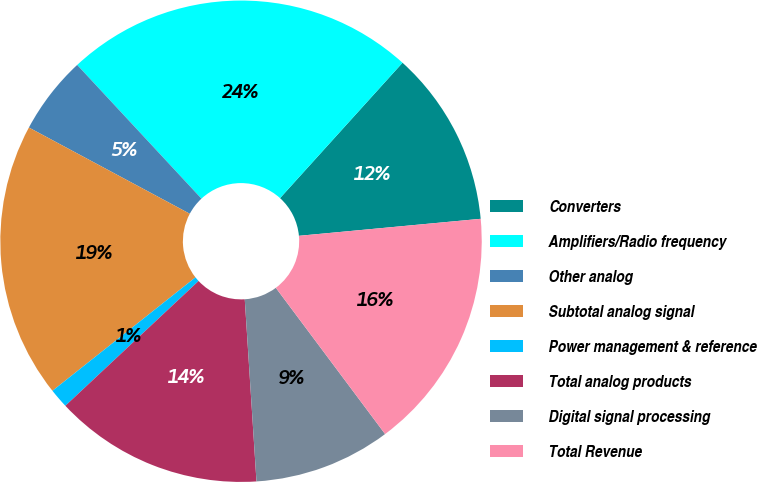<chart> <loc_0><loc_0><loc_500><loc_500><pie_chart><fcel>Converters<fcel>Amplifiers/Radio frequency<fcel>Other analog<fcel>Subtotal analog signal<fcel>Power management & reference<fcel>Total analog products<fcel>Digital signal processing<fcel>Total Revenue<nl><fcel>11.81%<fcel>23.62%<fcel>5.25%<fcel>18.5%<fcel>1.31%<fcel>14.04%<fcel>9.19%<fcel>16.27%<nl></chart> 